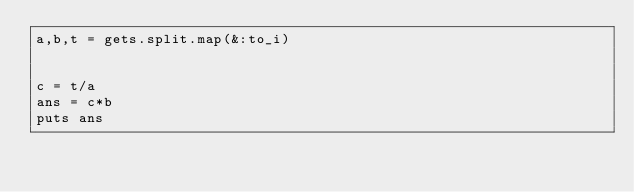Convert code to text. <code><loc_0><loc_0><loc_500><loc_500><_Ruby_>a,b,t = gets.split.map(&:to_i)


c = t/a
ans = c*b
puts ans
</code> 